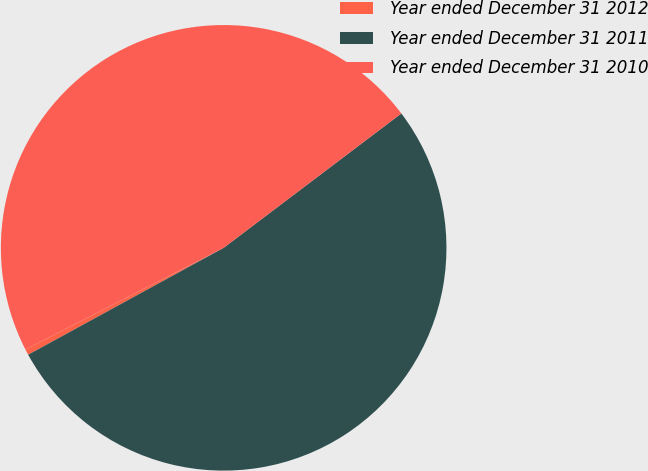<chart> <loc_0><loc_0><loc_500><loc_500><pie_chart><fcel>Year ended December 31 2012<fcel>Year ended December 31 2011<fcel>Year ended December 31 2010<nl><fcel>0.42%<fcel>52.34%<fcel>47.24%<nl></chart> 